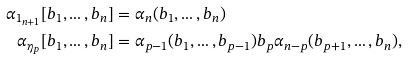<formula> <loc_0><loc_0><loc_500><loc_500>\alpha _ { 1 _ { n + 1 } } [ b _ { 1 } , \dots , b _ { n } ] & = \alpha _ { n } ( b _ { 1 } , \dots , b _ { n } ) \\ \alpha _ { \eta _ { p } } [ b _ { 1 } , \dots , b _ { n } ] & = \alpha _ { p - 1 } ( b _ { 1 } , \dots , b _ { p - 1 } ) b _ { p } \alpha _ { n - p } ( b _ { p + 1 } , \dots , b _ { n } ) ,</formula> 